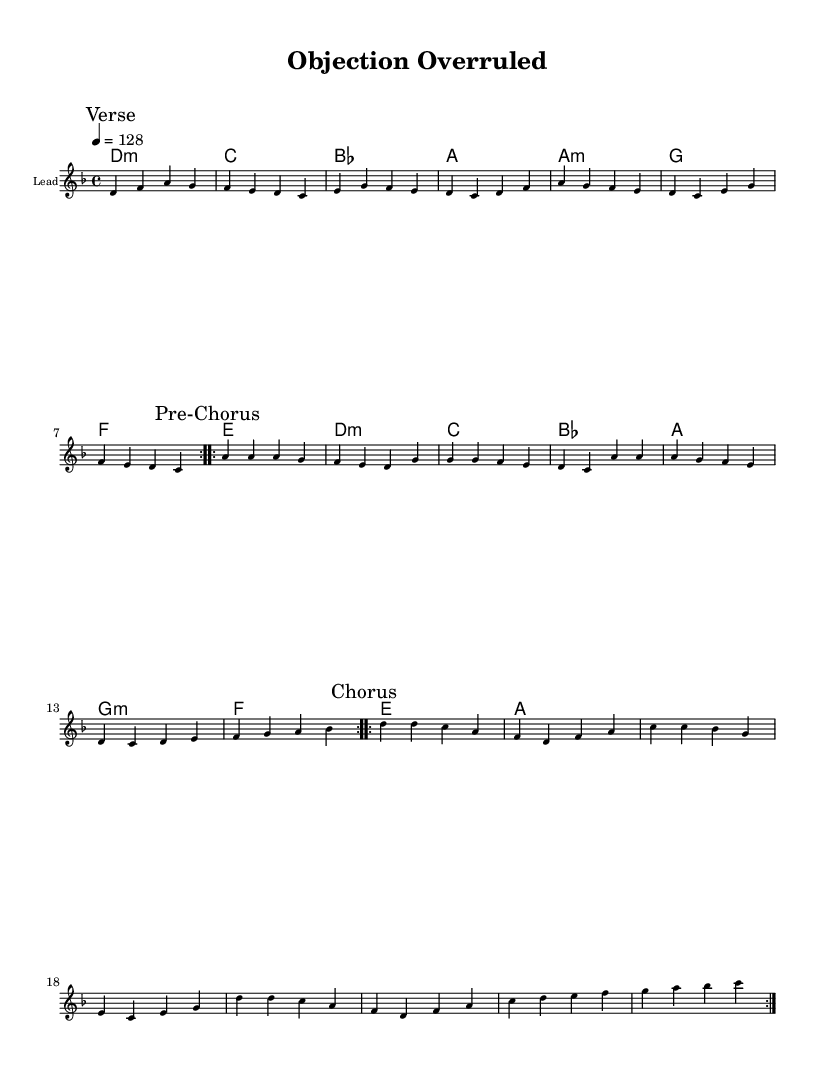What is the key signature of this music? The key signature is D minor, which is indicated by one flat (B♭) in the music.
Answer: D minor What is the time signature of this music? The time signature is 4/4, meaning there are four beats in each measure, and the quarter note receives one beat.
Answer: 4/4 What is the tempo marking of this piece? The tempo marking is 128 beats per minute, as indicated by "4 = 128" in the score, which indicates the speed at which to perform the music.
Answer: 128 How many times is the verse repeated? The verse section is repeated 2 times, as indicated by the "repeat volta 2" instruction at the beginning of that section.
Answer: 2 What is the last note of the chorus section? The last note of the chorus section is C, which is the final note at the end of the repeated chorus segment.
Answer: C What type of chord is used in the first measure? The first measure contains a D minor chord, which is specifically marked as "d1:m" in the chord notation, indicating it is a minor chord built on D.
Answer: D minor What is the overall mood created by this pop music's tempo and melody? The overall mood is energetic, as indicated by the fast tempo and upbeat melody pattern used throughout the sections.
Answer: Energetic 